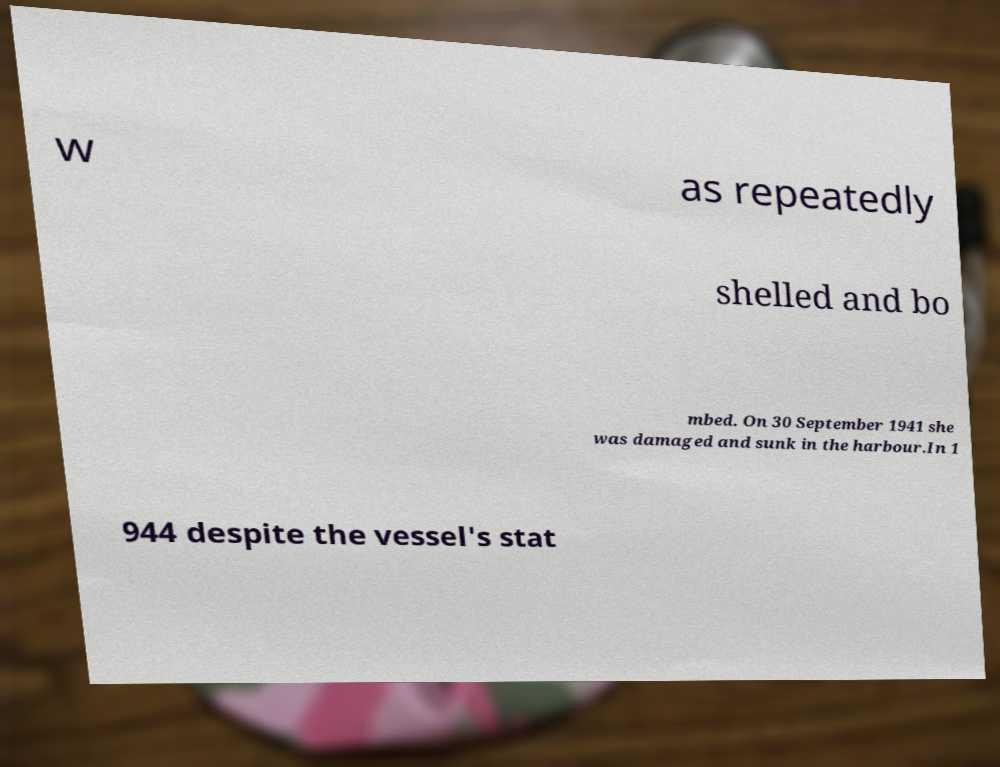Could you assist in decoding the text presented in this image and type it out clearly? w as repeatedly shelled and bo mbed. On 30 September 1941 she was damaged and sunk in the harbour.In 1 944 despite the vessel's stat 